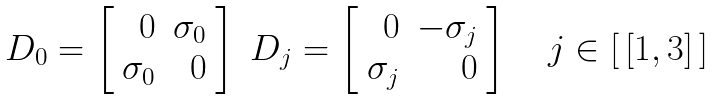Convert formula to latex. <formula><loc_0><loc_0><loc_500><loc_500>\begin{array} { l l } D _ { 0 } = \left [ \begin{array} { r r } 0 & \sigma _ { 0 } \\ \sigma _ { 0 } & 0 \end{array} \right ] & D _ { j } = \left [ \begin{array} { r r } 0 & - \sigma _ { j } \\ \sigma _ { j } & 0 \end{array} \right ] \quad j \in [ \, [ 1 , 3 ] \, ] \end{array}</formula> 